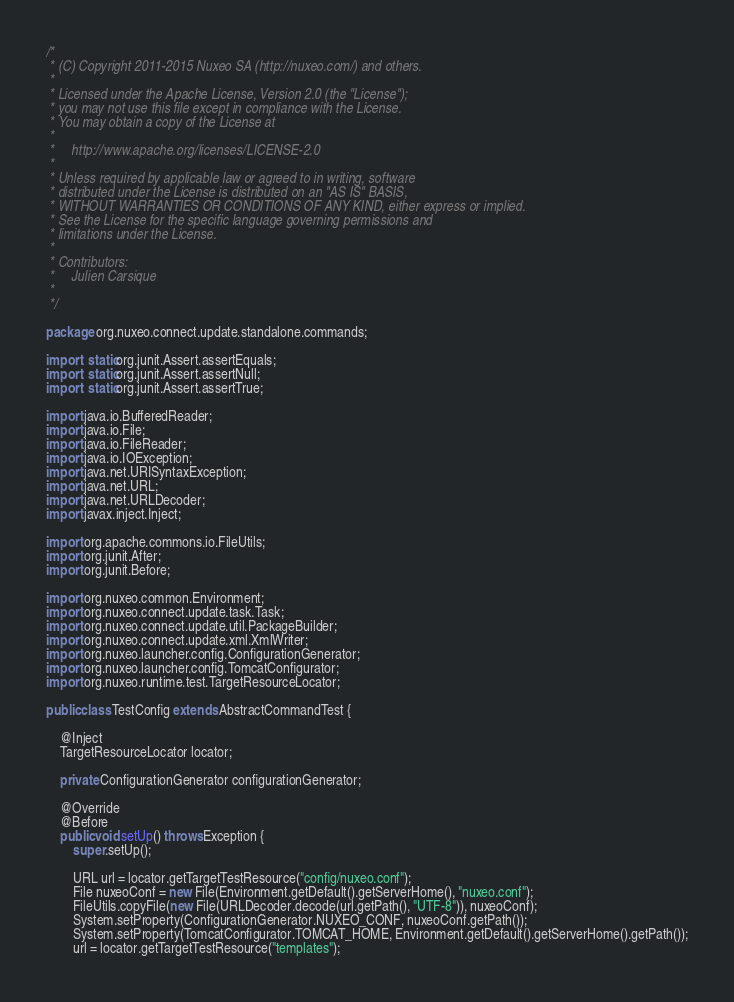<code> <loc_0><loc_0><loc_500><loc_500><_Java_>/*
 * (C) Copyright 2011-2015 Nuxeo SA (http://nuxeo.com/) and others.
 *
 * Licensed under the Apache License, Version 2.0 (the "License");
 * you may not use this file except in compliance with the License.
 * You may obtain a copy of the License at
 *
 *     http://www.apache.org/licenses/LICENSE-2.0
 *
 * Unless required by applicable law or agreed to in writing, software
 * distributed under the License is distributed on an "AS IS" BASIS,
 * WITHOUT WARRANTIES OR CONDITIONS OF ANY KIND, either express or implied.
 * See the License for the specific language governing permissions and
 * limitations under the License.
 *
 * Contributors:
 *     Julien Carsique
 *
 */

package org.nuxeo.connect.update.standalone.commands;

import static org.junit.Assert.assertEquals;
import static org.junit.Assert.assertNull;
import static org.junit.Assert.assertTrue;

import java.io.BufferedReader;
import java.io.File;
import java.io.FileReader;
import java.io.IOException;
import java.net.URISyntaxException;
import java.net.URL;
import java.net.URLDecoder;
import javax.inject.Inject;

import org.apache.commons.io.FileUtils;
import org.junit.After;
import org.junit.Before;

import org.nuxeo.common.Environment;
import org.nuxeo.connect.update.task.Task;
import org.nuxeo.connect.update.util.PackageBuilder;
import org.nuxeo.connect.update.xml.XmlWriter;
import org.nuxeo.launcher.config.ConfigurationGenerator;
import org.nuxeo.launcher.config.TomcatConfigurator;
import org.nuxeo.runtime.test.TargetResourceLocator;

public class TestConfig extends AbstractCommandTest {

    @Inject
    TargetResourceLocator locator;

    private ConfigurationGenerator configurationGenerator;

    @Override
    @Before
    public void setUp() throws Exception {
        super.setUp();

        URL url = locator.getTargetTestResource("config/nuxeo.conf");
        File nuxeoConf = new File(Environment.getDefault().getServerHome(), "nuxeo.conf");
        FileUtils.copyFile(new File(URLDecoder.decode(url.getPath(), "UTF-8")), nuxeoConf);
        System.setProperty(ConfigurationGenerator.NUXEO_CONF, nuxeoConf.getPath());
        System.setProperty(TomcatConfigurator.TOMCAT_HOME, Environment.getDefault().getServerHome().getPath());
        url = locator.getTargetTestResource("templates");</code> 